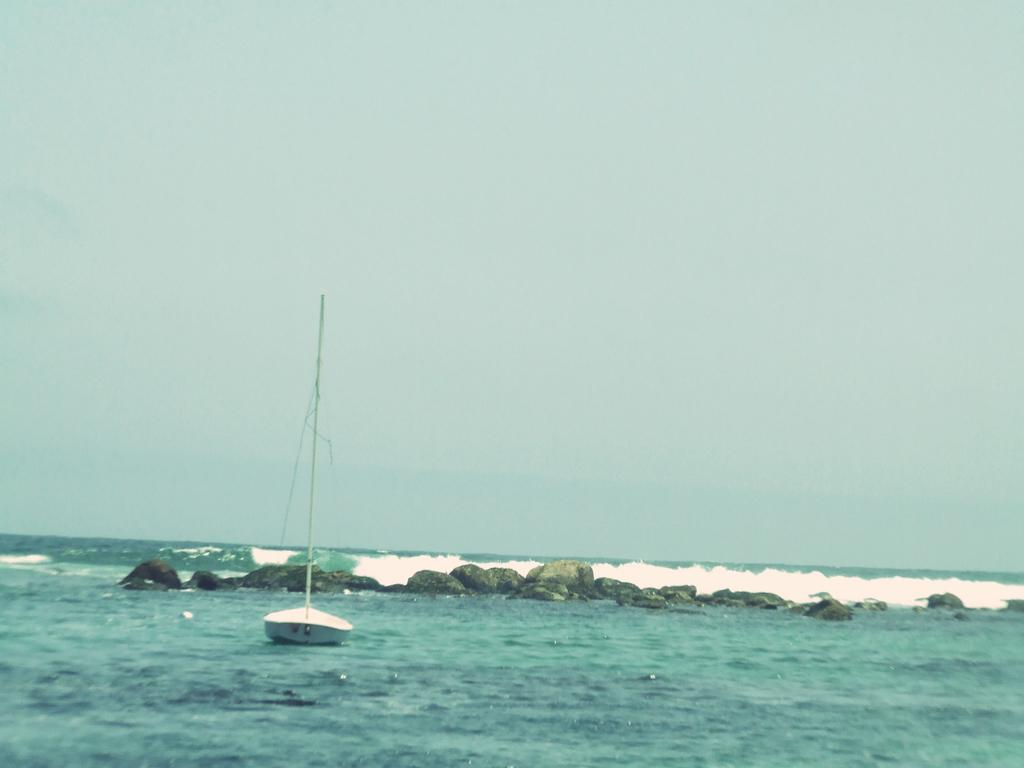What is the primary element visible in the image? There is water in the image. What can be found within the water? There is an object in the water. What type of natural elements can be seen in the image? Stones are visible in the image. What is visible above the water in the image? The sky is visible in the image. What type of theory is being discussed by the brush in the image? There is no brush or discussion of a theory present in the image. 